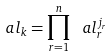<formula> <loc_0><loc_0><loc_500><loc_500>\ a l _ { k } = \prod _ { r = 1 } ^ { n } \ a l _ { r } ^ { j _ { r } }</formula> 